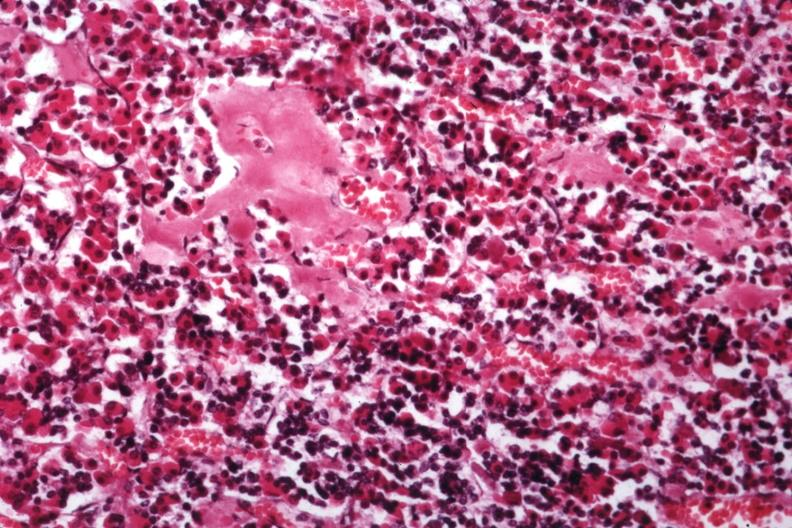what are several slides from this case in this file 23 yowf amyloid limited to brain?
Answer the question using a single word or phrase. There 